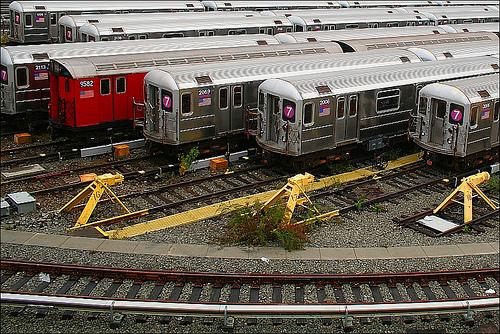How many train tracks are there?
Keep it brief. 6. How is one train different from the others?
Give a very brief answer. Red. What kind of vehicle can be seen?
Quick response, please. Train. 